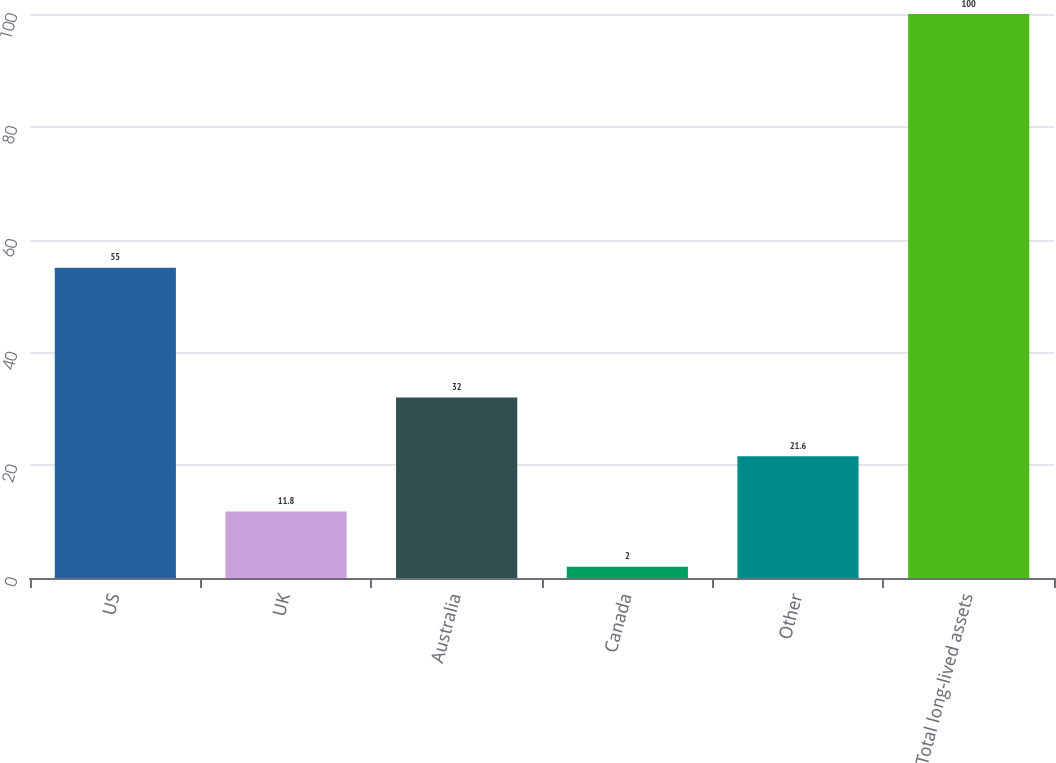Convert chart. <chart><loc_0><loc_0><loc_500><loc_500><bar_chart><fcel>US<fcel>UK<fcel>Australia<fcel>Canada<fcel>Other<fcel>Total long-lived assets<nl><fcel>55<fcel>11.8<fcel>32<fcel>2<fcel>21.6<fcel>100<nl></chart> 